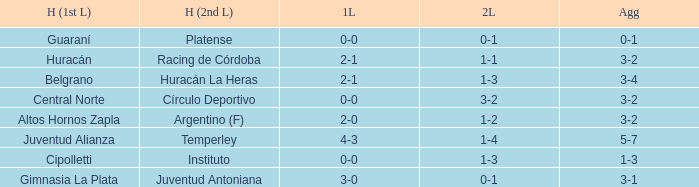Which team played their first leg at home with an aggregate score of 3-4? Belgrano. 